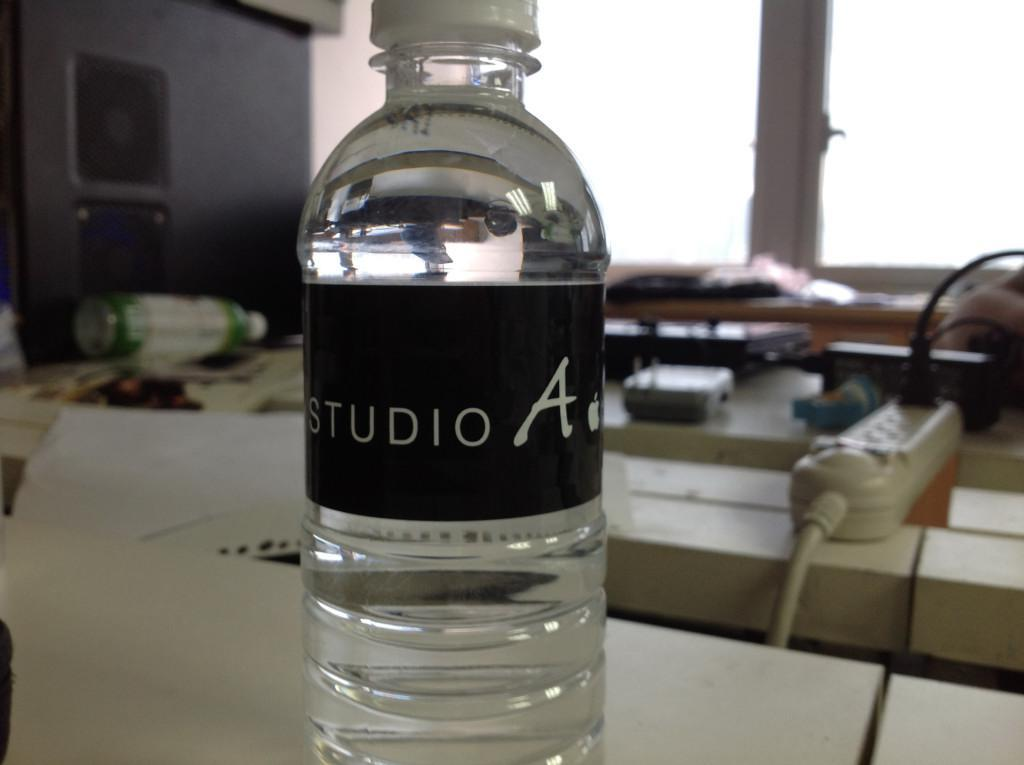<image>
Describe the image concisely. a clear water bottle with a black label that says 'studio a' 